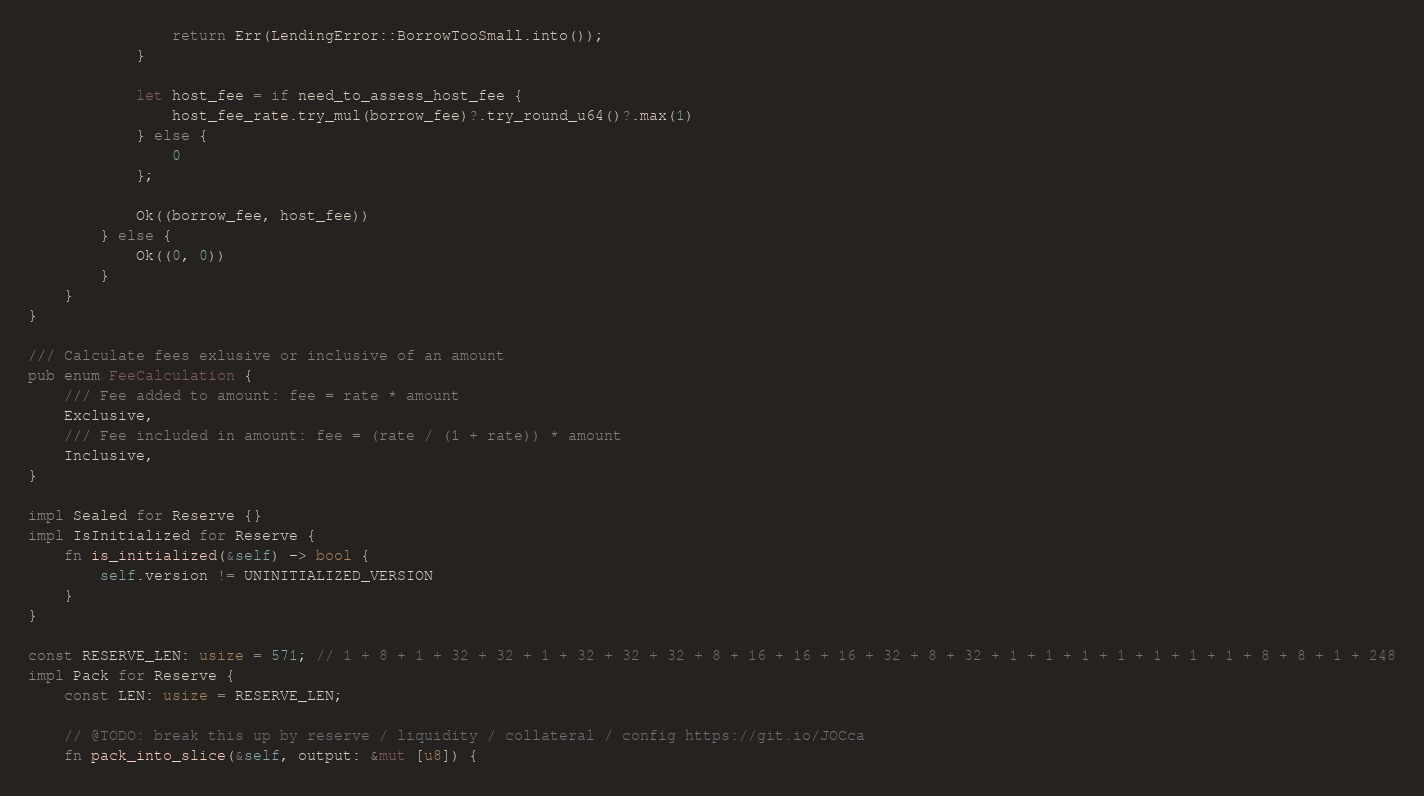Convert code to text. <code><loc_0><loc_0><loc_500><loc_500><_Rust_>                return Err(LendingError::BorrowTooSmall.into());
            }

            let host_fee = if need_to_assess_host_fee {
                host_fee_rate.try_mul(borrow_fee)?.try_round_u64()?.max(1)
            } else {
                0
            };

            Ok((borrow_fee, host_fee))
        } else {
            Ok((0, 0))
        }
    }
}

/// Calculate fees exlusive or inclusive of an amount
pub enum FeeCalculation {
    /// Fee added to amount: fee = rate * amount
    Exclusive,
    /// Fee included in amount: fee = (rate / (1 + rate)) * amount
    Inclusive,
}

impl Sealed for Reserve {}
impl IsInitialized for Reserve {
    fn is_initialized(&self) -> bool {
        self.version != UNINITIALIZED_VERSION
    }
}

const RESERVE_LEN: usize = 571; // 1 + 8 + 1 + 32 + 32 + 1 + 32 + 32 + 32 + 8 + 16 + 16 + 16 + 32 + 8 + 32 + 1 + 1 + 1 + 1 + 1 + 1 + 1 + 8 + 8 + 1 + 248
impl Pack for Reserve {
    const LEN: usize = RESERVE_LEN;

    // @TODO: break this up by reserve / liquidity / collateral / config https://git.io/JOCca
    fn pack_into_slice(&self, output: &mut [u8]) {</code> 